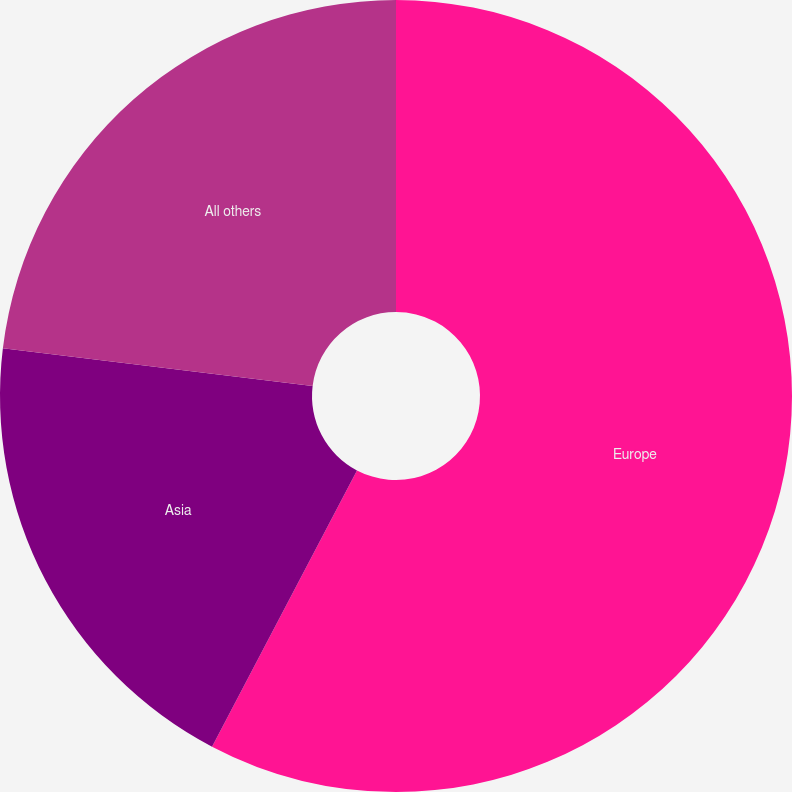Convert chart. <chart><loc_0><loc_0><loc_500><loc_500><pie_chart><fcel>Europe<fcel>Asia<fcel>All others<nl><fcel>57.69%<fcel>19.23%<fcel>23.08%<nl></chart> 